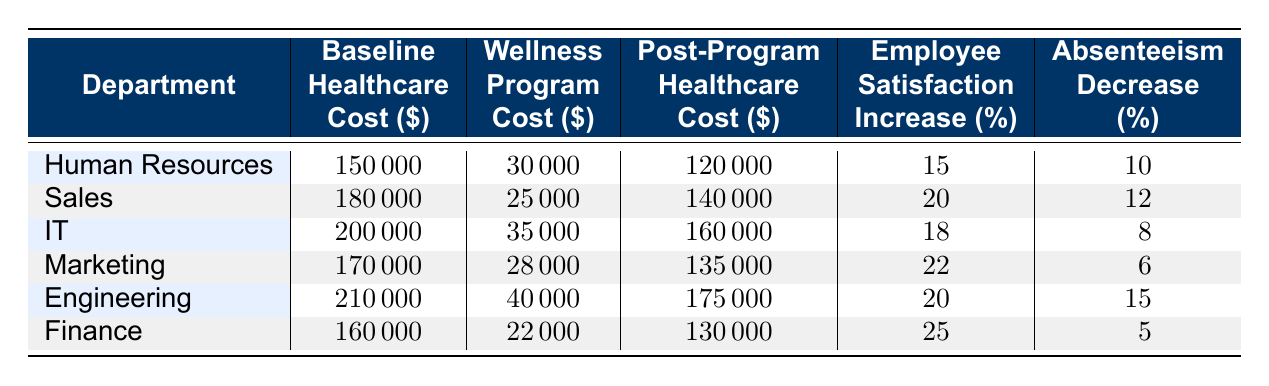What is the baseline healthcare cost for the Sales department? The baseline healthcare cost for the Sales department is explicitly listed in the table under the corresponding column. By locating the row for Sales, the value is 180,000.
Answer: 180000 Which department had the highest employee satisfaction increase percentage? By examining the employee satisfaction increase percent column for all departments, we can see that Finance has the highest value at 25 percent.
Answer: Finance What is the total wellness program cost for the Engineering and IT departments combined? To calculate the total wellness program cost for Engineering and IT, we take their individual costs (40,000 for Engineering and 35,000 for IT) and add them together: 40,000 + 35,000 = 75,000.
Answer: 75000 Is the post-program healthcare cost for the Human Resources department lower than the baseline healthcare cost for the Marketing department? The post-program healthcare cost for Human Resources is 120,000, which is lower than the baseline healthcare cost for Marketing, which is 170,000. Therefore, the statement is true.
Answer: Yes Which department experienced the greatest reduction in absenteeism percentage after implementing the wellness program? We can observe the absenteeism decrease percentage for each department and see that Engineering has the highest reduction at 15 percent.
Answer: Engineering What is the average employee satisfaction increase percentage across all departments? To find the average employee satisfaction increase percentage, we first sum all the percentages (15+20+18+22+20+25 = 120) and then divide by the number of departments (6). Therefore, the average is 120/6 = 20.
Answer: 20 Did the IT department experience a higher increase in employee satisfaction compared to the Engineering department? From the table, we see that the IT department had an employee satisfaction increase of 18 percent, while Engineering had an increase of 20 percent. Therefore, IT did not experience a higher increase.
Answer: No What is the difference between the baseline healthcare costs of the Human Resources and Finance departments? To calculate the difference, we subtract the baseline healthcare cost of Finance (160,000) from that of Human Resources (150,000): 150,000 - 160,000 = -10,000. This indicates that Human Resources has a lower baseline healthcare cost.
Answer: -10000 